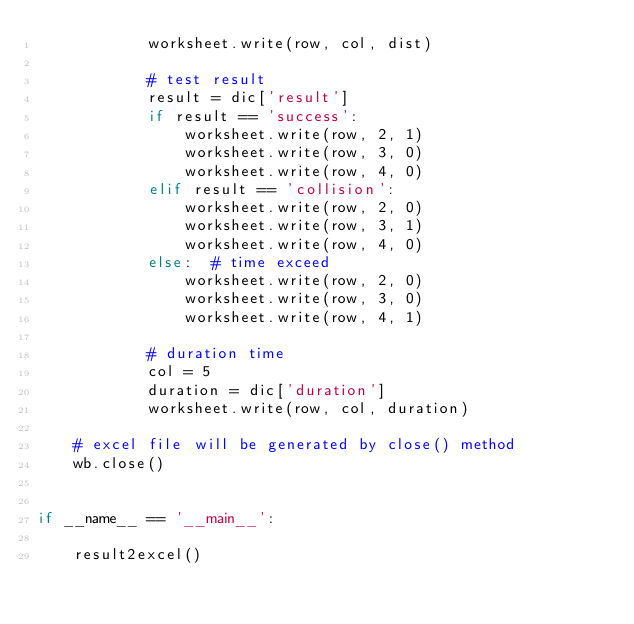Convert code to text. <code><loc_0><loc_0><loc_500><loc_500><_Python_>            worksheet.write(row, col, dist)

            # test result
            result = dic['result']
            if result == 'success':
                worksheet.write(row, 2, 1)
                worksheet.write(row, 3, 0)
                worksheet.write(row, 4, 0)
            elif result == 'collision':
                worksheet.write(row, 2, 0)
                worksheet.write(row, 3, 1)
                worksheet.write(row, 4, 0)
            else:  # time exceed
                worksheet.write(row, 2, 0)
                worksheet.write(row, 3, 0)
                worksheet.write(row, 4, 1)

            # duration time
            col = 5
            duration = dic['duration']
            worksheet.write(row, col, duration)

    # excel file will be generated by close() method
    wb.close()


if __name__ == '__main__':

    result2excel()
</code> 